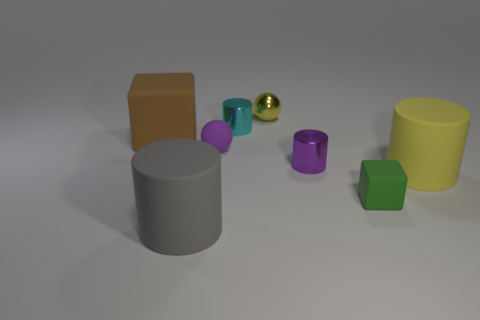What number of things are small metallic cylinders in front of the tiny cyan metal object or tiny purple things on the right side of the tiny yellow object?
Your response must be concise. 1. What shape is the brown object that is the same size as the gray matte cylinder?
Give a very brief answer. Cube. Are there any big matte objects of the same shape as the cyan shiny thing?
Provide a succinct answer. Yes. Is the number of big yellow matte cylinders less than the number of big blue metallic cylinders?
Provide a succinct answer. No. Do the brown rubber block behind the gray matte thing and the rubber cylinder to the right of the gray cylinder have the same size?
Provide a short and direct response. Yes. How many objects are either large brown rubber objects or small yellow objects?
Offer a very short reply. 2. There is a ball behind the tiny cyan thing; what size is it?
Offer a very short reply. Small. There is a purple rubber ball behind the matte cylinder that is to the right of the big gray cylinder; how many tiny cylinders are behind it?
Make the answer very short. 1. How many tiny objects are both on the right side of the yellow metal thing and left of the green rubber block?
Make the answer very short. 1. There is a small metallic object in front of the big block; what is its shape?
Provide a short and direct response. Cylinder. 